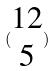Convert formula to latex. <formula><loc_0><loc_0><loc_500><loc_500>( \begin{matrix} 1 2 \\ 5 \end{matrix} )</formula> 